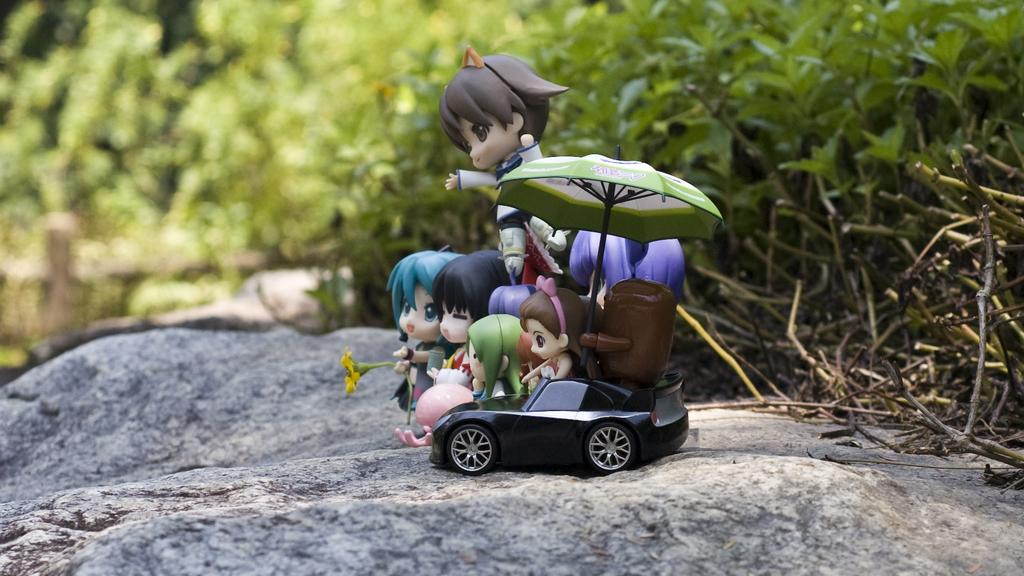What objects are on the rock in the image? There are toys on a rock in the image. What type of vegetation is on the right side of the image? There are plants on the right side of the image. Can you describe the background of the image? The background of the image is blurry. What type of ornament is present in the image? There is no ornament present in the image. How does the bomb affect the toys on the rock in the image? There is no bomb present in the image, so it cannot affect the toys on the rock. 